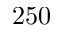Convert formula to latex. <formula><loc_0><loc_0><loc_500><loc_500>2 5 0</formula> 